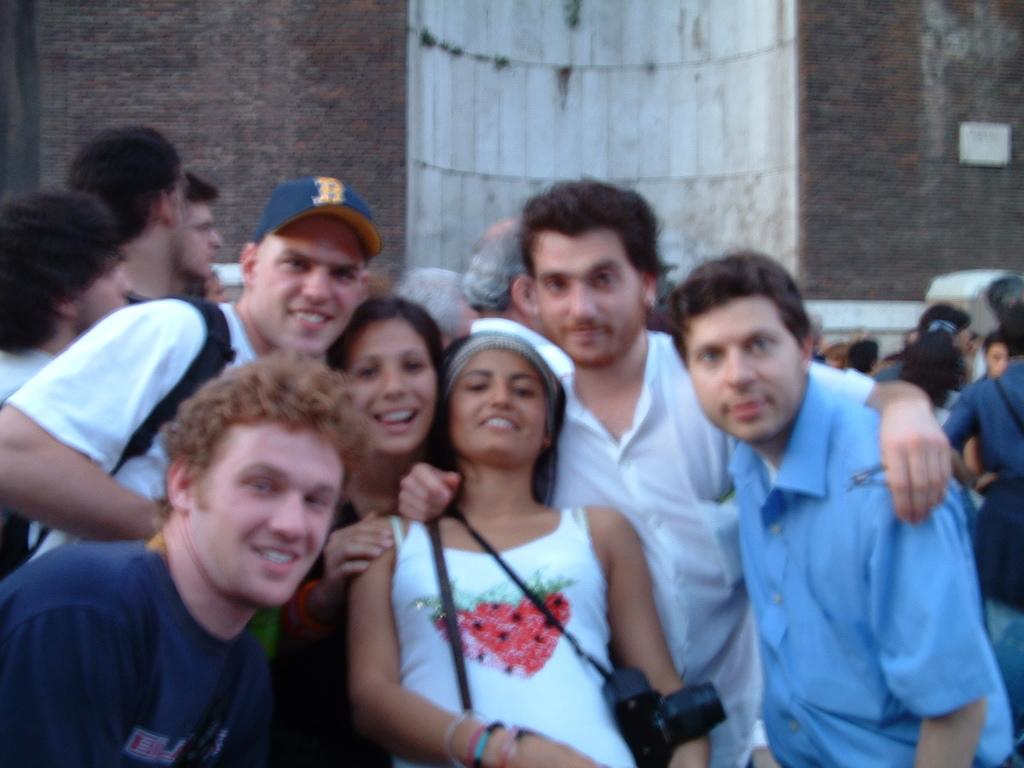How many people are in the image? There are people in the image, but the exact number is not specified. What are some people doing in the image? Some people are carrying bags, and others are carrying a camera. What can be seen in the background of the image? There is a wall in the background of the image. What type of net is being used by the people in the image? There is no net present in the image. What color is the skirt worn by the person in the image? There is no person wearing a skirt in the image. 